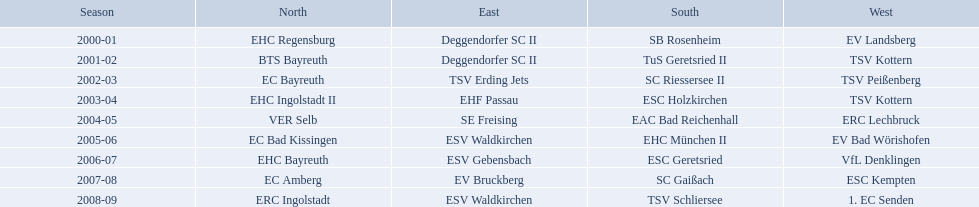Which teams won the north in their respective years? 2000-01, EHC Regensburg, BTS Bayreuth, EC Bayreuth, EHC Ingolstadt II, VER Selb, EC Bad Kissingen, EHC Bayreuth, EC Amberg, ERC Ingolstadt. Which one only won in 2000-01? EHC Regensburg. 